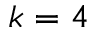Convert formula to latex. <formula><loc_0><loc_0><loc_500><loc_500>k = 4</formula> 